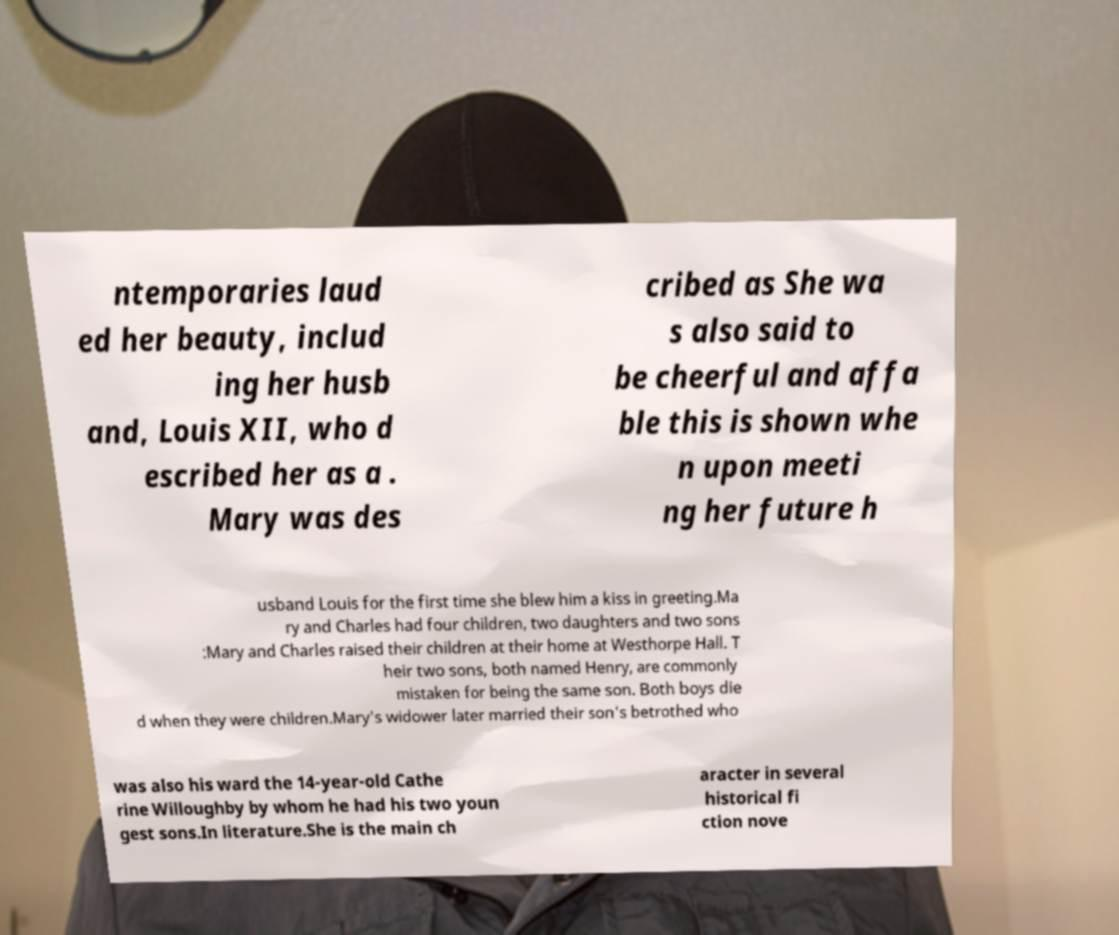What messages or text are displayed in this image? I need them in a readable, typed format. ntemporaries laud ed her beauty, includ ing her husb and, Louis XII, who d escribed her as a . Mary was des cribed as She wa s also said to be cheerful and affa ble this is shown whe n upon meeti ng her future h usband Louis for the first time she blew him a kiss in greeting.Ma ry and Charles had four children, two daughters and two sons :Mary and Charles raised their children at their home at Westhorpe Hall. T heir two sons, both named Henry, are commonly mistaken for being the same son. Both boys die d when they were children.Mary's widower later married their son's betrothed who was also his ward the 14-year-old Cathe rine Willoughby by whom he had his two youn gest sons.In literature.She is the main ch aracter in several historical fi ction nove 